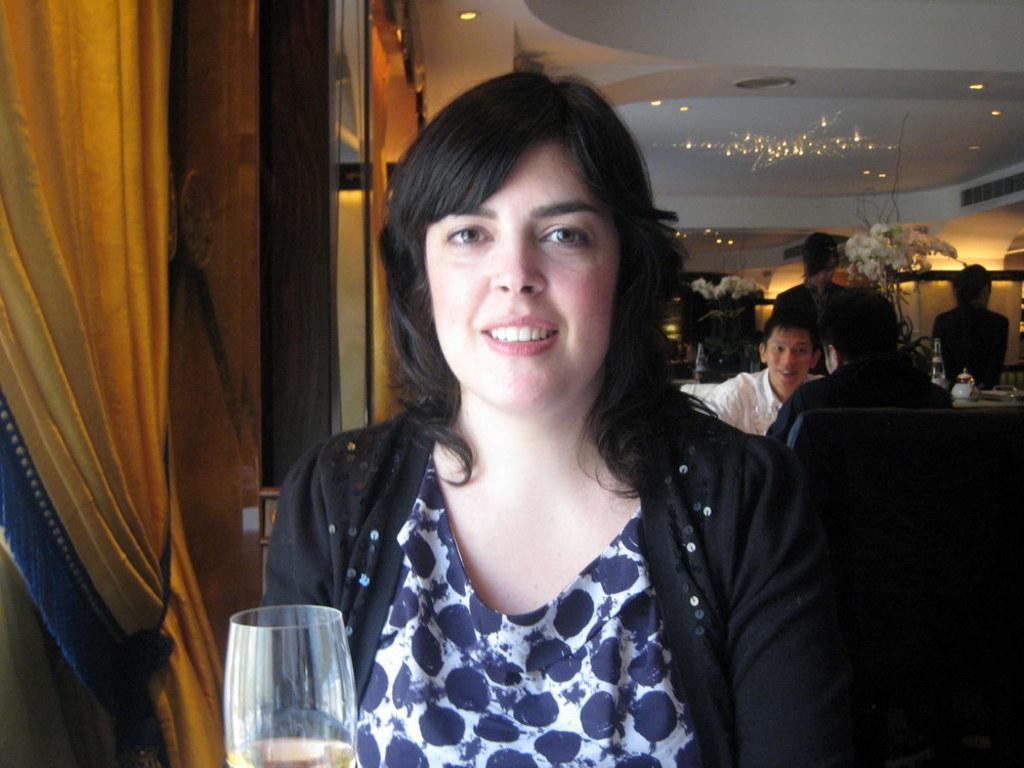Could you give a brief overview of what you see in this image? In the center of the image we can see a lady sitting. At the bottom there is a glass. In the background there are people sitting and we can see decors. On the left there is a curtain and we can see lights. There is a table and we can see things placed on the table. 